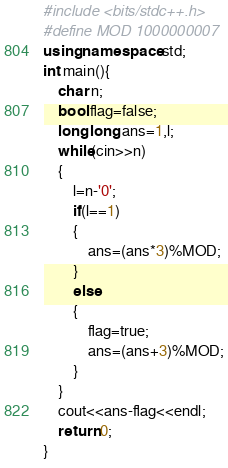<code> <loc_0><loc_0><loc_500><loc_500><_C++_>#include <bits/stdc++.h>
#define MOD 1000000007
using namespace std;
int main(){
	char n;
	bool flag=false;
	long long ans=1,l;
	while(cin>>n)
	{
		l=n-'0';
		if(l==1)
		{
			ans=(ans*3)%MOD;
		}
		else
		{
			flag=true;
			ans=(ans+3)%MOD;
		}
	}
	cout<<ans-flag<<endl;
	return 0;
}</code> 